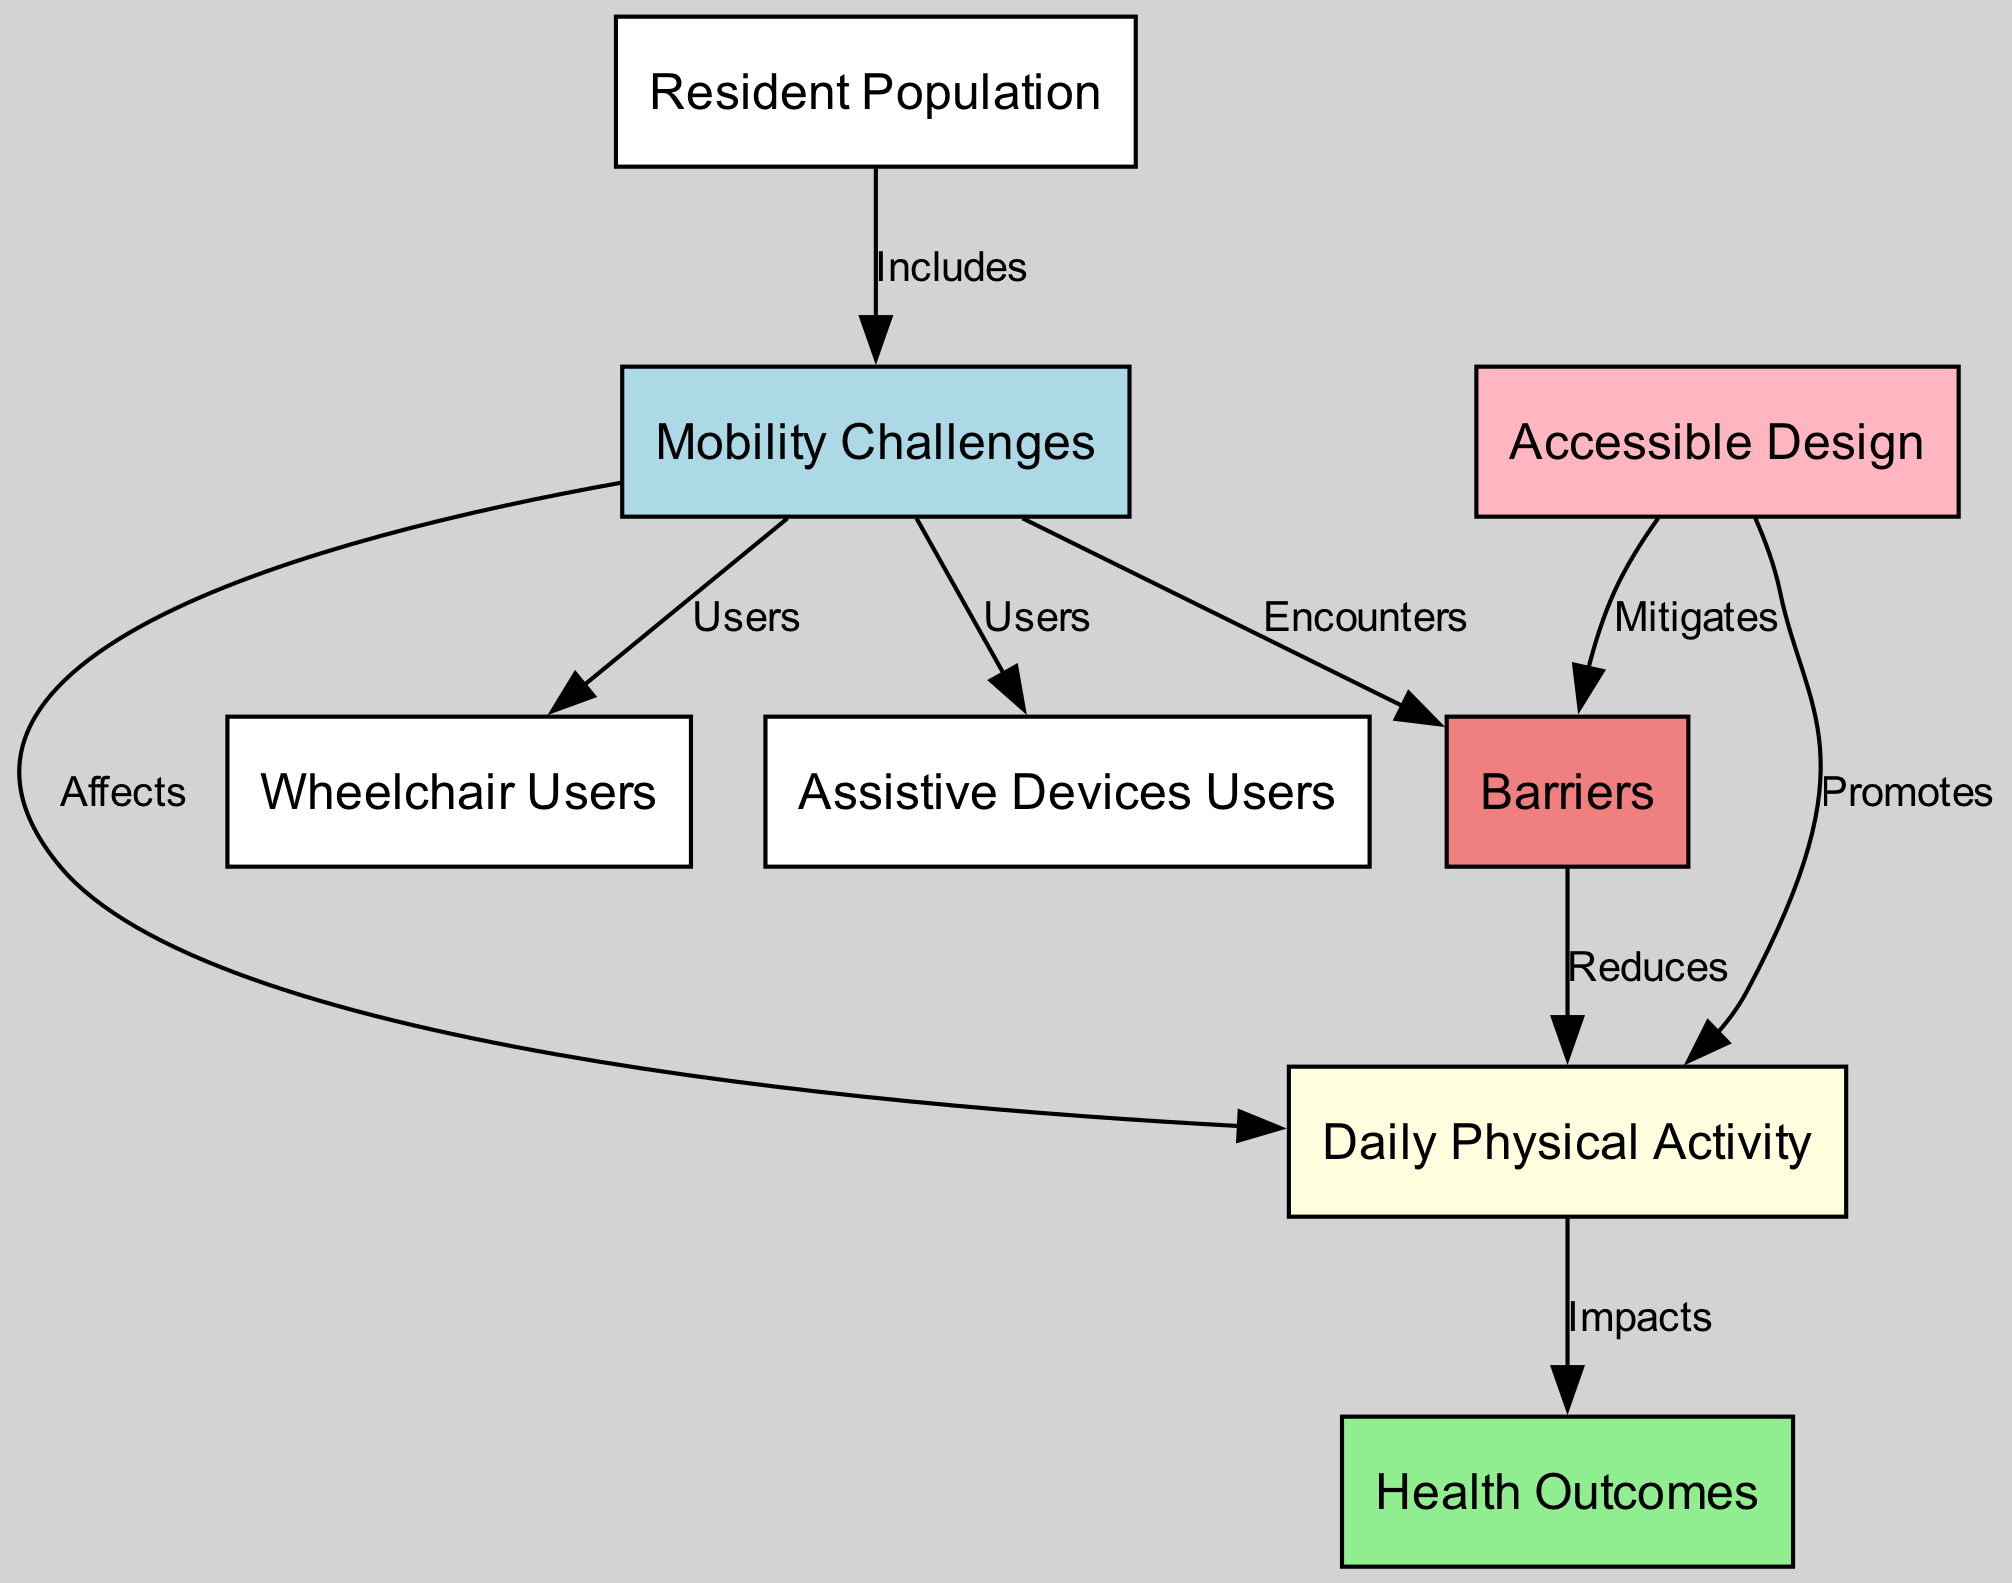What is the total number of nodes in the diagram? The diagram has 8 distinct nodes representing different elements relevant to daily physical activity levels in residents with mobility challenges.
Answer: 8 Which node represents users of assistive devices? The node labeled "Assistive Devices Users" specifically identifies individuals who utilize assistive devices as part of their mobility challenges.
Answer: Assistive Devices Users What does the "Barriers" node affect? The "Barriers" node has a directed edge pointing towards the "Daily Physical Activity" node, indicating that barriers reduce daily physical activity levels.
Answer: Daily Physical Activity How does "Accessible Design" relate to "Barriers"? The edge from the "Accessible Design" node to the "Barriers" node indicates that accessible design can mitigate the barriers faced by residents with mobility challenges.
Answer: Mitigates What type of health outcomes are impacted by daily physical activity? The edge from "Daily Physical Activity" to "Health Outcomes" signifies that there are positive health outcomes resulting from higher levels of daily physical activity among residents.
Answer: Health Outcomes How many edges are connected to the "Mobility Challenges" node? The "Mobility Challenges" node connects to four edges, signifying multiple relationships including users of wheelchairs, assistive devices, effects on daily physical activity, and encounters with barriers.
Answer: 4 What promotes increased daily physical activity according to the diagram? The "Accessible Design" node has a directed edge to "Daily Physical Activity", indicating that accessible design promotes greater physical activity levels among residents.
Answer: Promotes Which node is directly impacted by "Barriers"? The "Daily Physical Activity" node is directly impacted by barriers, as indicated by the reduction effect shown in the directed edge from the "Barriers" node.
Answer: Daily Physical Activity 